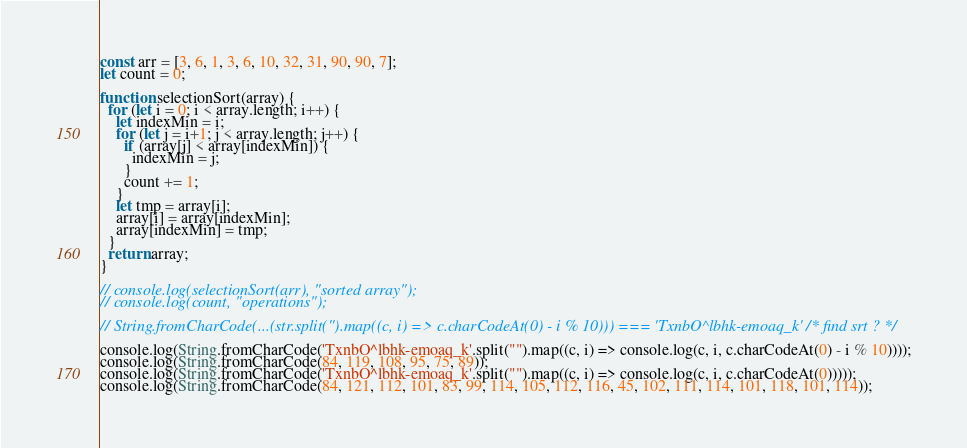<code> <loc_0><loc_0><loc_500><loc_500><_JavaScript_>const arr = [3, 6, 1, 3, 6, 10, 32, 31, 90, 90, 7];
let count = 0;

function selectionSort(array) {
  for (let i = 0; i < array.length; i++) {
    let indexMin = i;
    for (let j = i+1; j < array.length; j++) {
      if (array[j] < array[indexMin]) {
        indexMin = j;
      }
      count += 1;
    }
    let tmp = array[i];
    array[i] = array[indexMin];
    array[indexMin] = tmp;
  }
  return array;
}

// console.log(selectionSort(arr), "sorted array");
// console.log(count, "operations");

// String.fromCharCode(...(str.split('').map((c, i) => c.charCodeAt(0) - i % 10))) === 'TxnbO^lbhk-emoaq_k' /* find srt ? */

console.log(String.fromCharCode('TxnbO^lbhk-emoaq_k'.split("").map((c, i) => console.log(c, i, c.charCodeAt(0) - i % 10))));
console.log(String.fromCharCode(84, 119, 108, 95, 75, 89));
console.log(String.fromCharCode('TxnbO^lbhk-emoaq_k'.split("").map((c, i) => console.log(c, i, c.charCodeAt(0)))));
console.log(String.fromCharCode(84, 121, 112, 101, 83, 99, 114, 105, 112, 116, 45, 102, 111, 114, 101, 118, 101, 114));</code> 